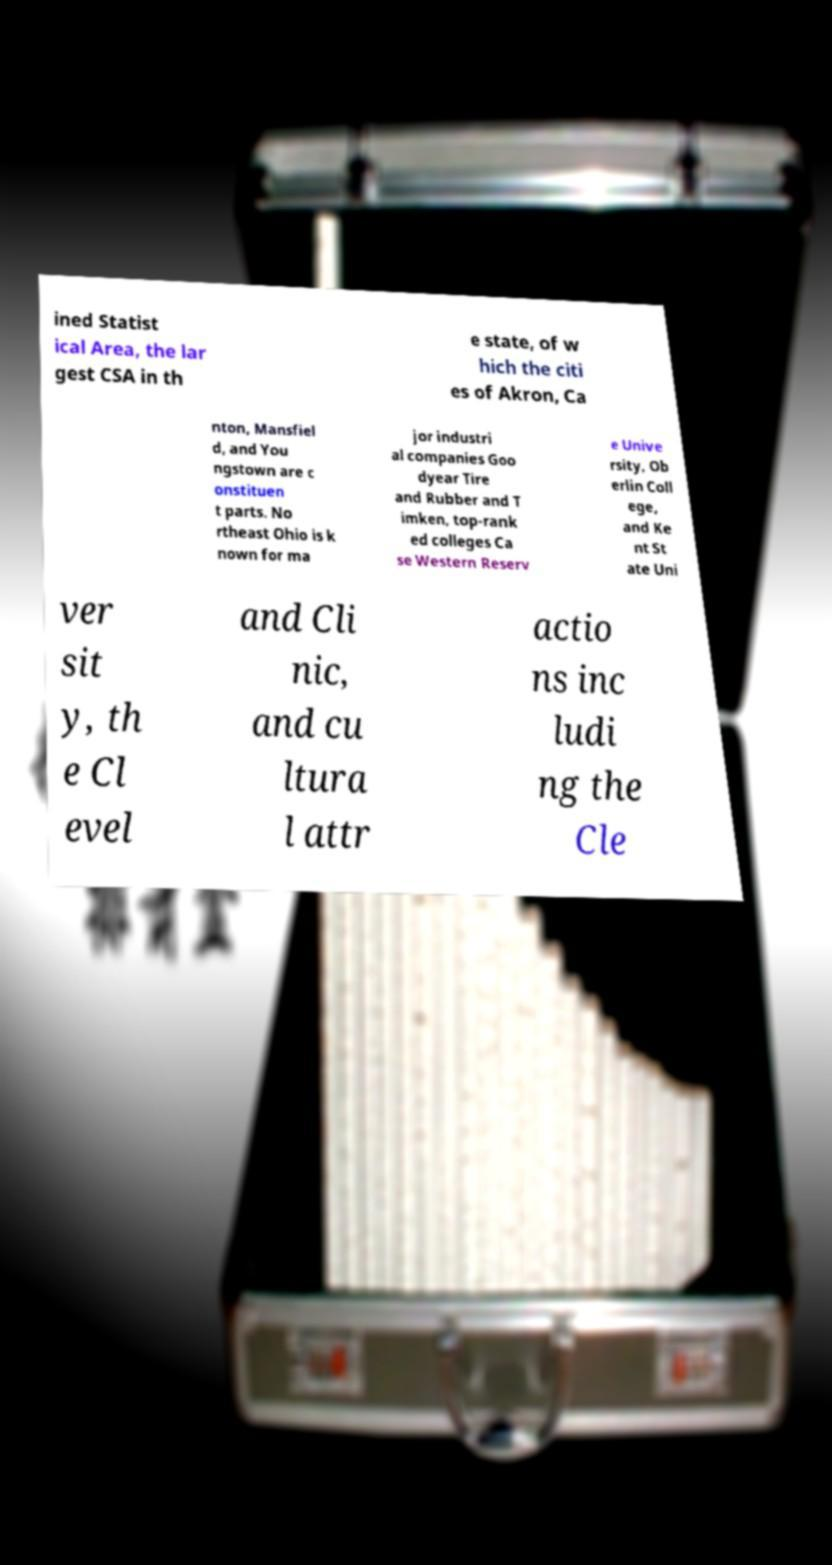For documentation purposes, I need the text within this image transcribed. Could you provide that? ined Statist ical Area, the lar gest CSA in th e state, of w hich the citi es of Akron, Ca nton, Mansfiel d, and You ngstown are c onstituen t parts. No rtheast Ohio is k nown for ma jor industri al companies Goo dyear Tire and Rubber and T imken, top-rank ed colleges Ca se Western Reserv e Unive rsity, Ob erlin Coll ege, and Ke nt St ate Uni ver sit y, th e Cl evel and Cli nic, and cu ltura l attr actio ns inc ludi ng the Cle 